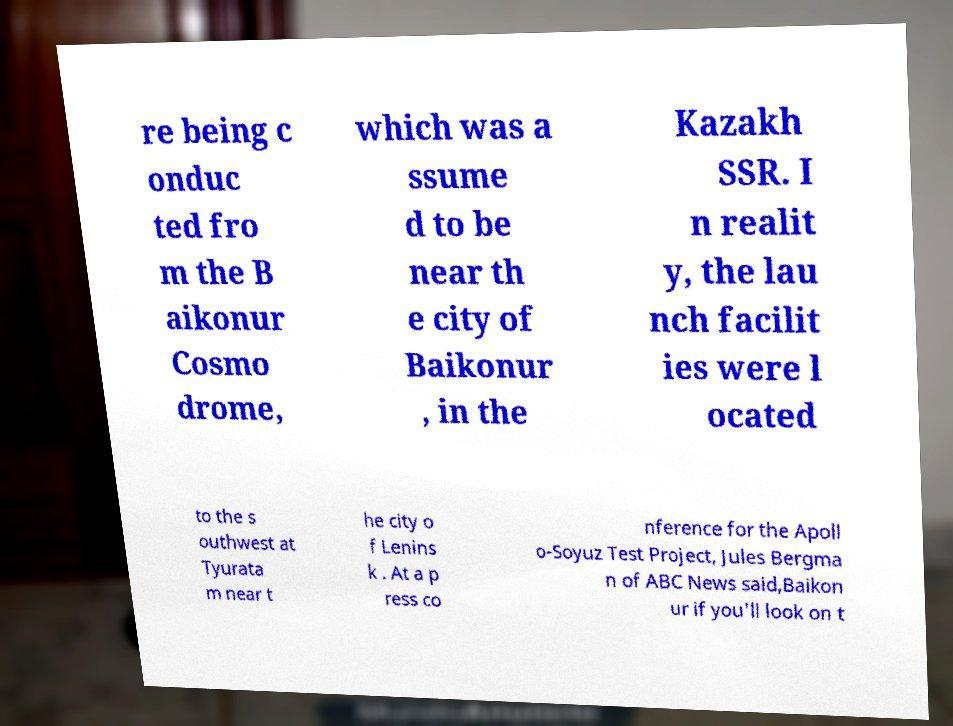Could you assist in decoding the text presented in this image and type it out clearly? re being c onduc ted fro m the B aikonur Cosmo drome, which was a ssume d to be near th e city of Baikonur , in the Kazakh SSR. I n realit y, the lau nch facilit ies were l ocated to the s outhwest at Tyurata m near t he city o f Lenins k . At a p ress co nference for the Apoll o-Soyuz Test Project, Jules Bergma n of ABC News said,Baikon ur if you'll look on t 